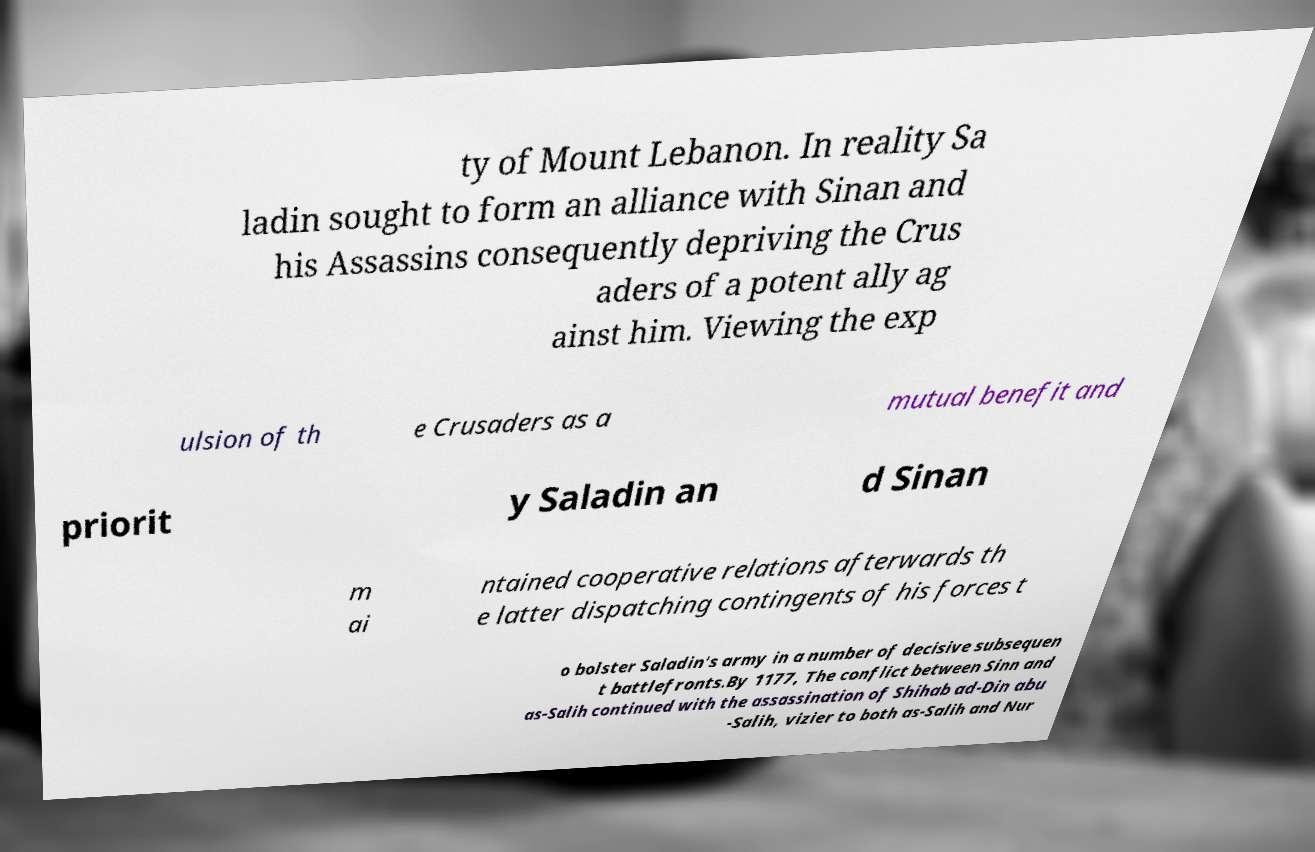There's text embedded in this image that I need extracted. Can you transcribe it verbatim? ty of Mount Lebanon. In reality Sa ladin sought to form an alliance with Sinan and his Assassins consequently depriving the Crus aders of a potent ally ag ainst him. Viewing the exp ulsion of th e Crusaders as a mutual benefit and priorit y Saladin an d Sinan m ai ntained cooperative relations afterwards th e latter dispatching contingents of his forces t o bolster Saladin's army in a number of decisive subsequen t battlefronts.By 1177, The conflict between Sinn and as-Salih continued with the assassination of Shihab ad-Din abu -Salih, vizier to both as-Salih and Nur 